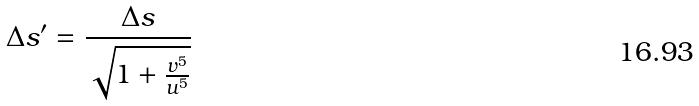<formula> <loc_0><loc_0><loc_500><loc_500>\Delta s ^ { \prime } = \frac { \Delta s } { \sqrt { 1 + \frac { v ^ { 5 } } { u ^ { 5 } } } }</formula> 